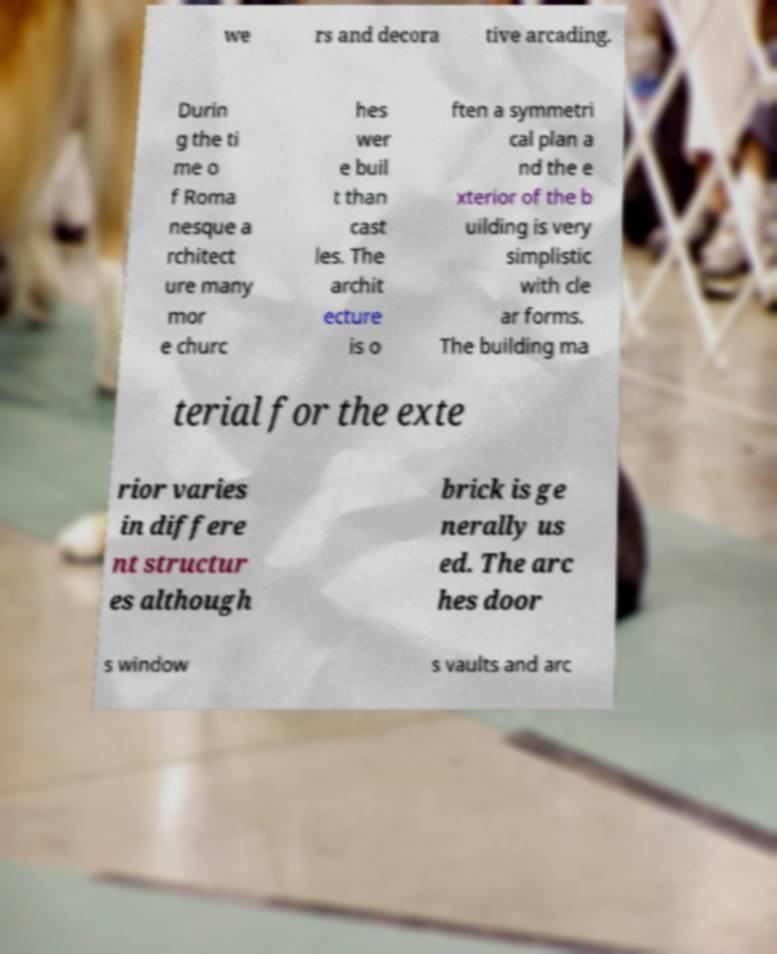There's text embedded in this image that I need extracted. Can you transcribe it verbatim? we rs and decora tive arcading. Durin g the ti me o f Roma nesque a rchitect ure many mor e churc hes wer e buil t than cast les. The archit ecture is o ften a symmetri cal plan a nd the e xterior of the b uilding is very simplistic with cle ar forms. The building ma terial for the exte rior varies in differe nt structur es although brick is ge nerally us ed. The arc hes door s window s vaults and arc 